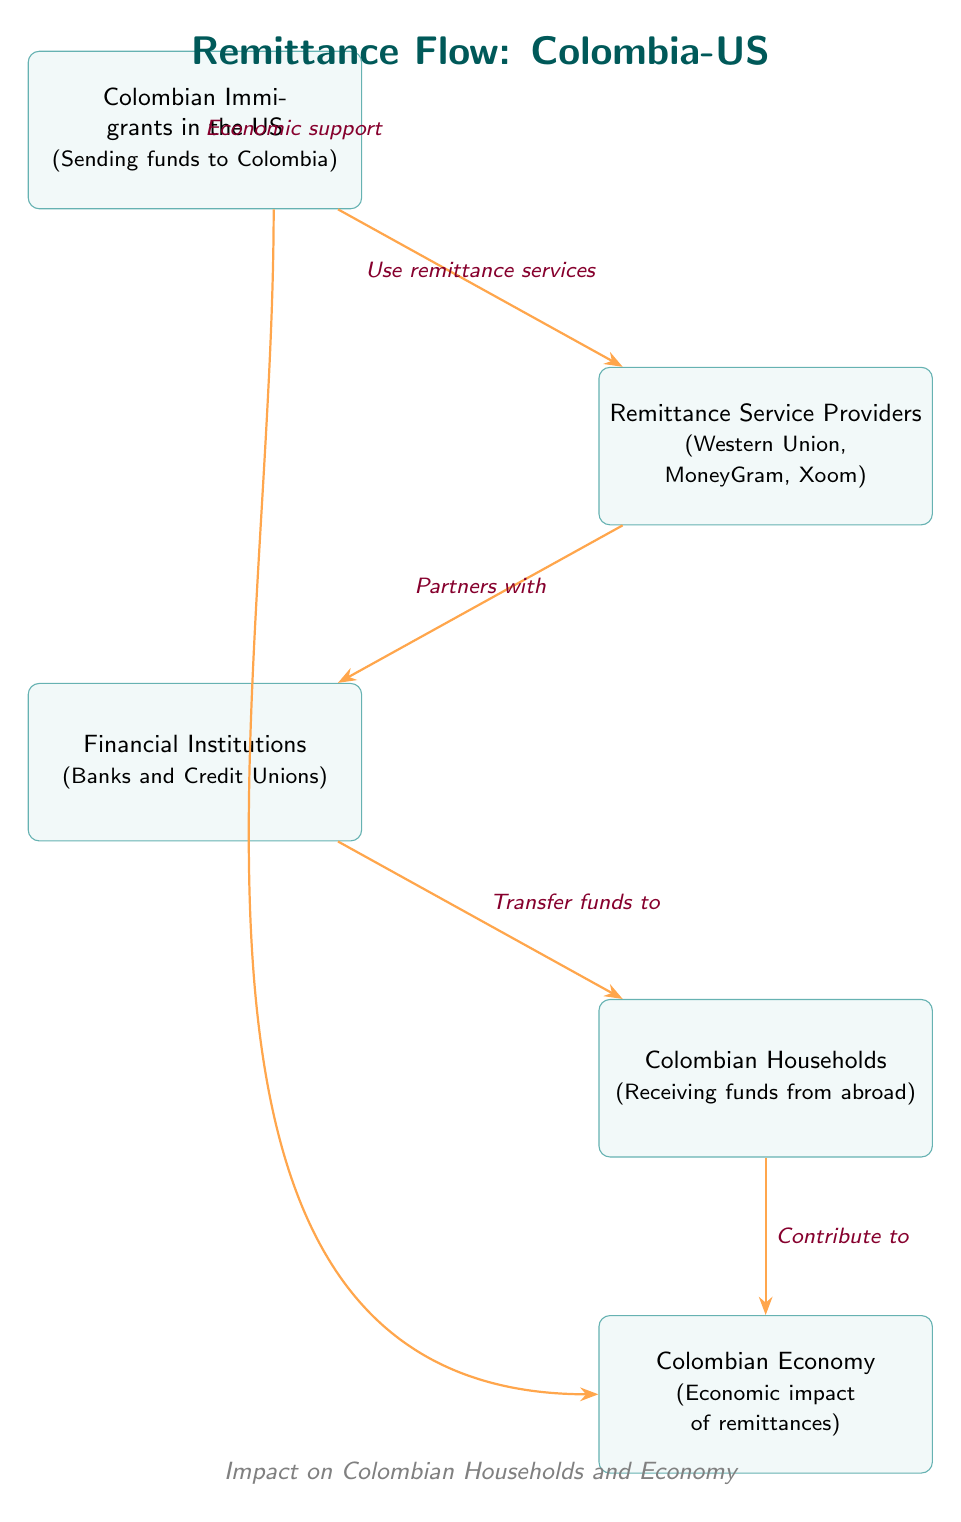What is the starting point of the remittance flow? The starting point of the remittance flow is the node labeled "Colombian Immigrants in the US." This node represents the individuals who send funds back home to Colombia.
Answer: Colombian Immigrants in the US How many nodes are present in the diagram? To determine the number of nodes, we can count each distinct box in the diagram. These boxes include immigrants, service providers, financial institutions, households, and the economy, totaling five nodes.
Answer: 5 What do remittance service providers partner with? The remittance service providers, represented by the node, are indicated to partner with the financial institutions. The arrow connecting these two nodes shows this direct relationship.
Answer: Financial Institutions How do Colombian households contribute economically? The diagram indicates that Colombian households contribute to the Colombian economy, as shown by the arrow pointing from the households to the economy node. This suggests that the remittance inflow from these households has an economic impact.
Answer: Contribute to What services do Colombian immigrants use to send funds? Colombian immigrants use remittance services to send funds, as indicated by the label on the arrow connecting the immigrants' node to the service providers' node. This label clearly specifies the action taken by the immigrants.
Answer: Use remittance services What is the flow of funds from financial institutions to Colombian households? The diagram shows an arrow from the financial institutions to the Colombian households, labeled "Transfer funds to." This indicates that the financial institutions facilitate the transfer of remitted funds to the households.
Answer: Transfer funds to What type of impact do remittances have on the Colombian economy? The remittances have an economic impact on the Colombian economy, depicted by the arrow from the households to the economy node, which indicates this contribution.
Answer: Economic impact of remittances What role do remittance service providers play in the flow? The remittance service providers act as intermediaries, receiving funds from the immigrants and then partnering with financial institutions to transfer these funds to Colombia. This captures their crucial role in the overall flow.
Answer: Partners with 